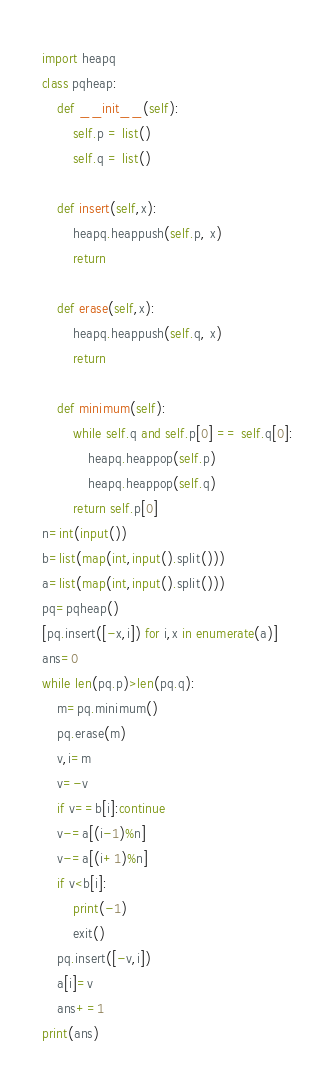<code> <loc_0><loc_0><loc_500><loc_500><_Python_>import heapq
class pqheap:
    def __init__(self):
        self.p = list()
        self.q = list()

    def insert(self,x):
        heapq.heappush(self.p, x)
        return

    def erase(self,x):
        heapq.heappush(self.q, x)
        return

    def minimum(self):
        while self.q and self.p[0] == self.q[0]:
            heapq.heappop(self.p)
            heapq.heappop(self.q)
        return self.p[0]
n=int(input())
b=list(map(int,input().split()))
a=list(map(int,input().split()))
pq=pqheap()
[pq.insert([-x,i]) for i,x in enumerate(a)]
ans=0
while len(pq.p)>len(pq.q):
    m=pq.minimum()
    pq.erase(m)
    v,i=m
    v=-v
    if v==b[i]:continue
    v-=a[(i-1)%n]
    v-=a[(i+1)%n]
    if v<b[i]:
        print(-1)
        exit()
    pq.insert([-v,i])
    a[i]=v
    ans+=1
print(ans)



</code> 